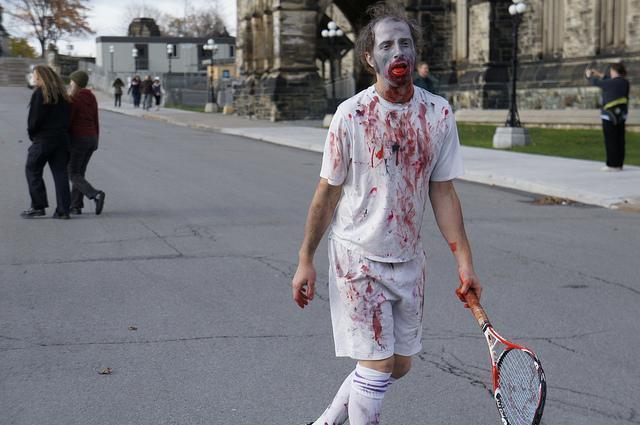How many people are there?
Give a very brief answer. 4. 